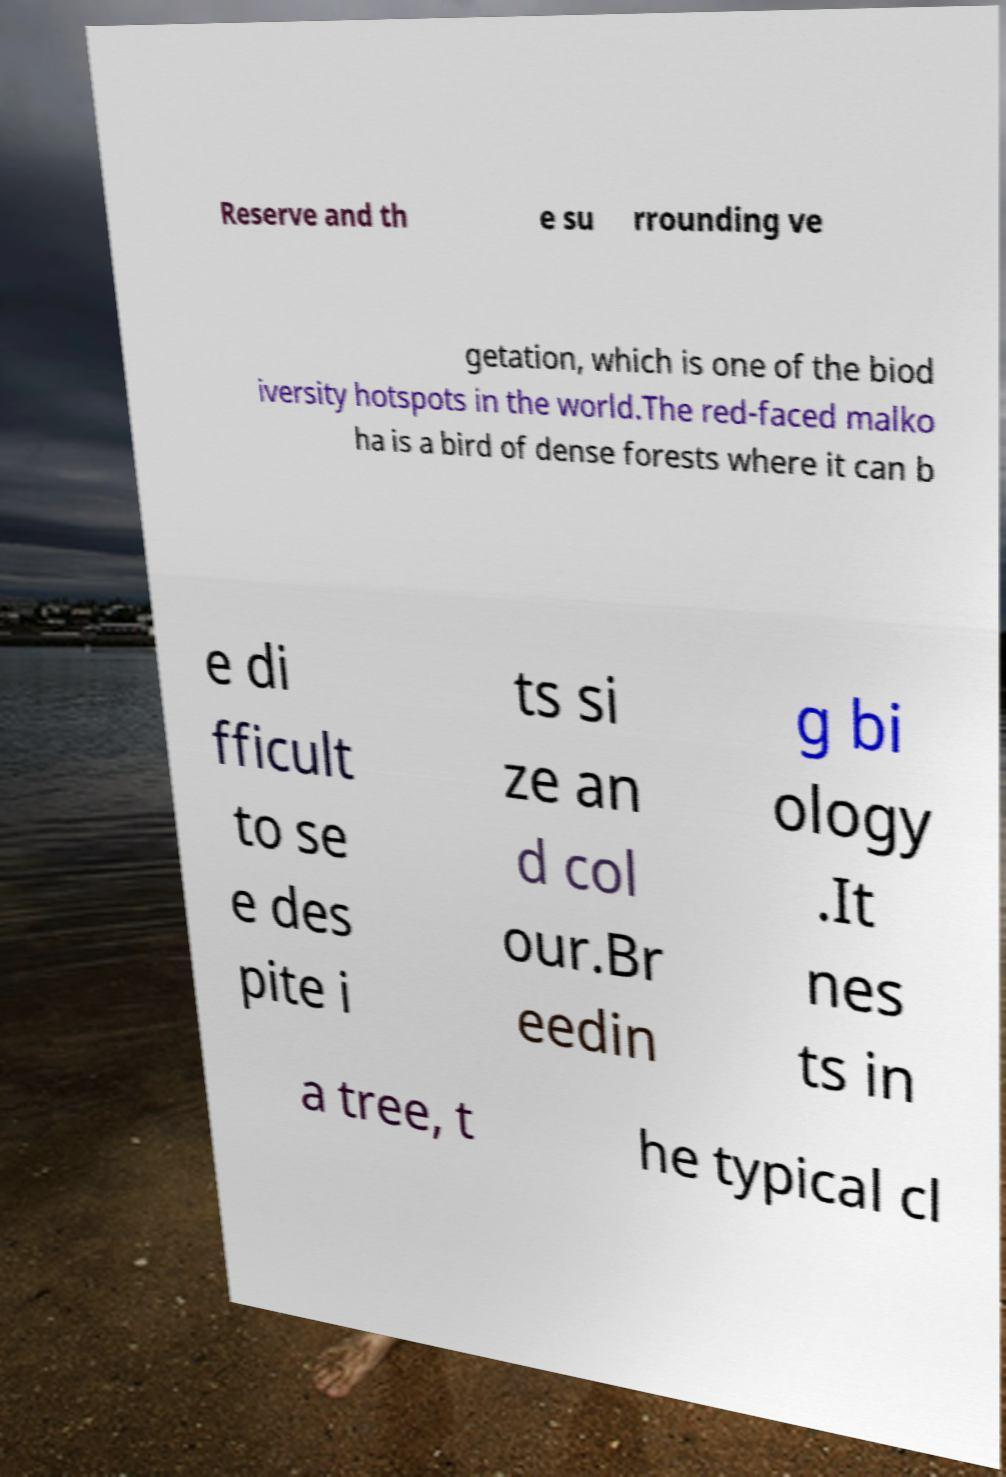Could you extract and type out the text from this image? Reserve and th e su rrounding ve getation, which is one of the biod iversity hotspots in the world.The red-faced malko ha is a bird of dense forests where it can b e di fficult to se e des pite i ts si ze an d col our.Br eedin g bi ology .It nes ts in a tree, t he typical cl 